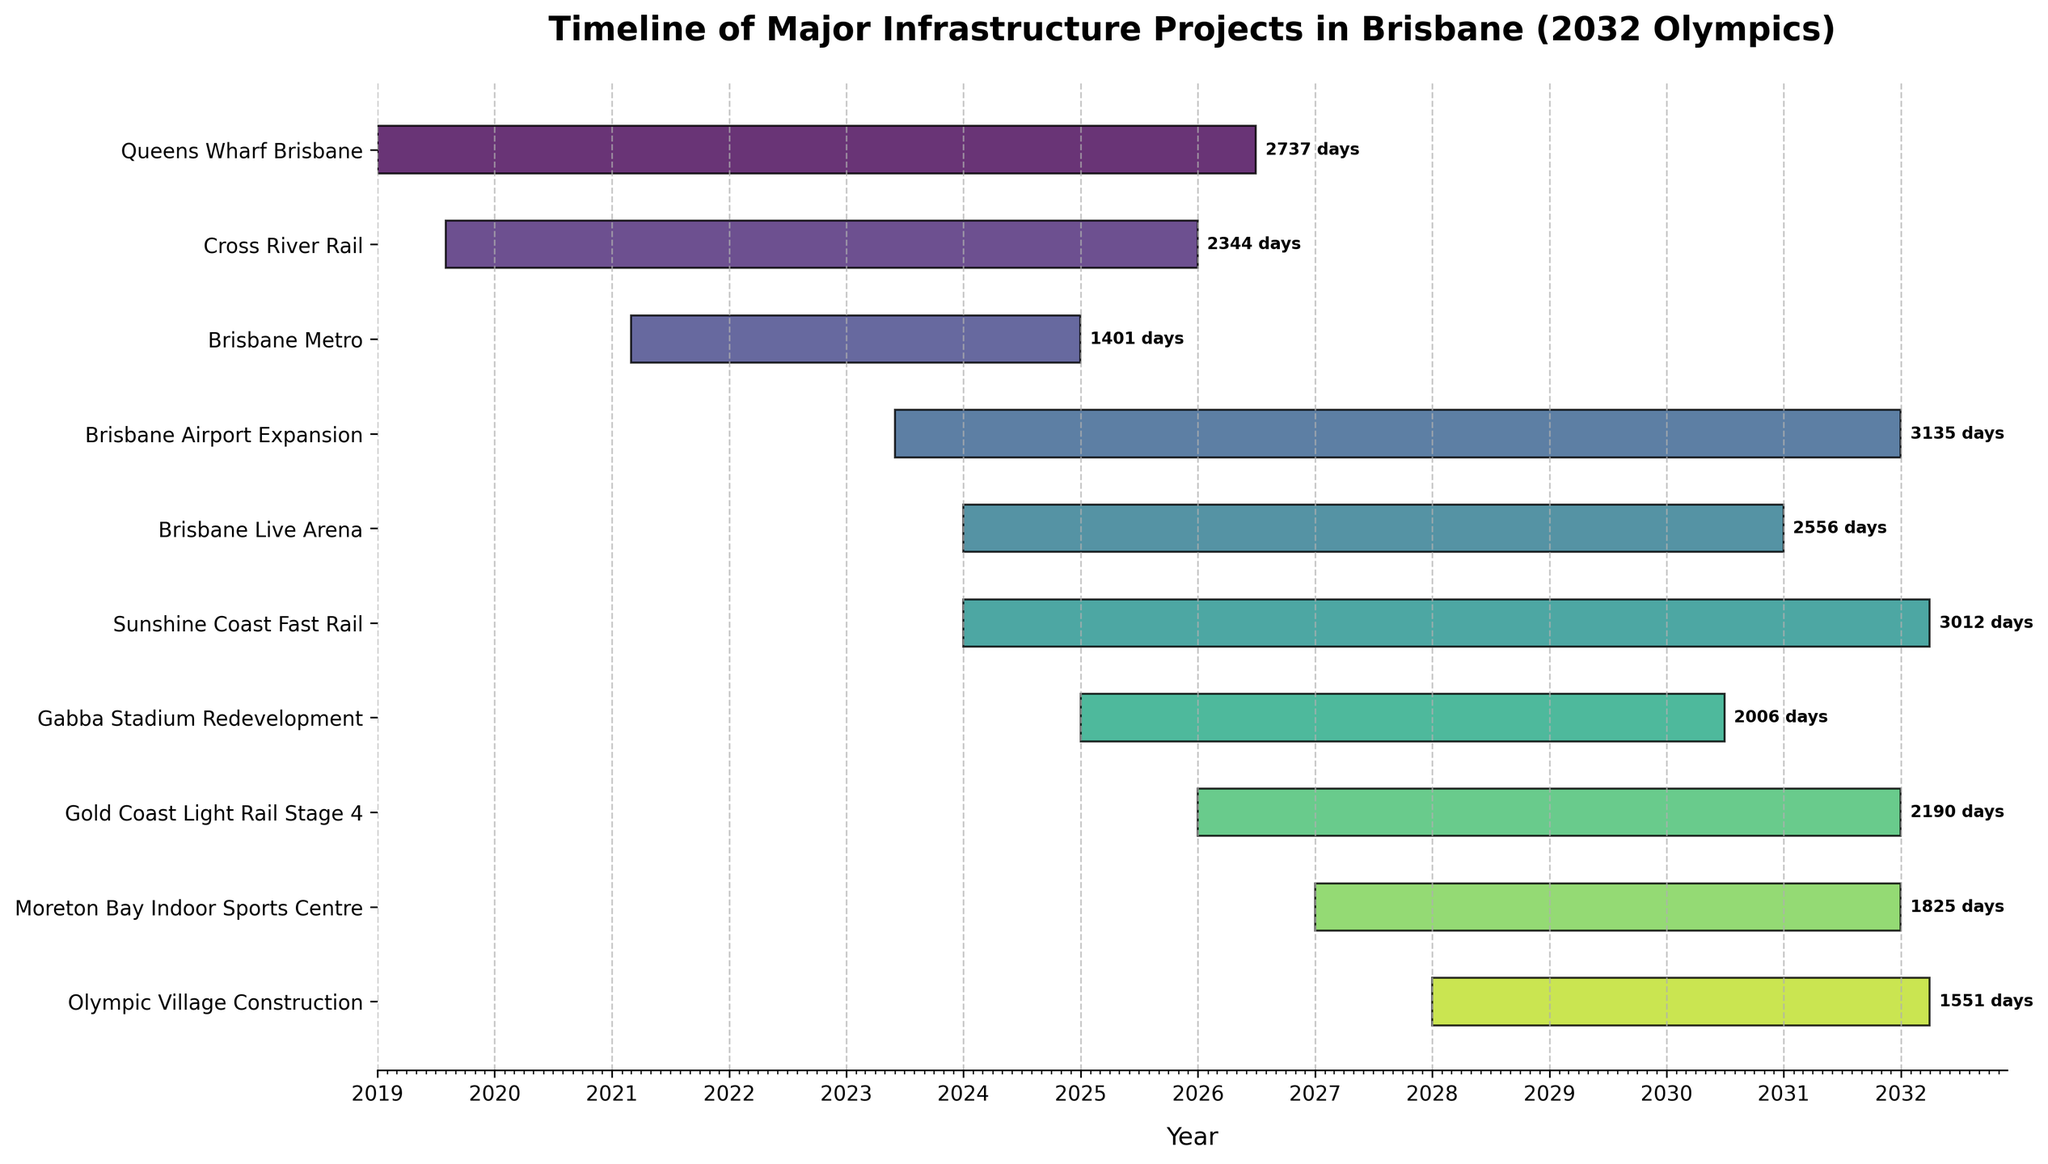What is the title of the Gantt chart? The title of a Gantt chart is typically located at the top center of the figure. By reading the title, we can identify the subject of the visualization.
Answer: Timeline of Major Infrastructure Projects in Brisbane (2032 Olympics) Which project is expected to finish first? To determine this, we look at the end dates on the right side of the bars in the chart. The project with the earliest end date finishes first.
Answer: Brisbane Metro What is the duration of the Cross River Rail project in days? The duration is given by the length of the bar. We can determine this by the text label at the end of the bar next to the project name, indicating the number of days.
Answer: 1614 days Which project has the longest duration? To identify the longest project, find the bar that spans the most years on the horizontal axis by comparing the lengths visually.
Answer: Olympic Village Construction Is the Gabba Stadium Redevelopment expected to be finished before the Sunshine Coast Fast Rail project starts? To answer this, we observe the end date of the Gabba Stadium Redevelopment and the start date of the Sunshine Coast Fast Rail project and compare them.
Answer: No During which years does the Brisbane Airport Expansion project take place? Examine the start and end dates of the Brisbane Airport Expansion bar to see how many and which years they span on the horizontal axis.
Answer: 2023-2031 Which projects are expected to start in the same year? Look at the left edges of the bars and identify the projects that begin within the same vertical line segment or year markers.
Answer: Brisbane Live Arena and Sunshine Coast Fast Rail (2024); Gold Coast Light Rail Stage 4 and Gabba Stadium Redevelopment (2026) What is the total number of projects expected to be completed by 2031? Identify and count the projects whose end dates are before or during the year 2031.
Answer: Five projects (Brisbane Metro, Cross River Rail, Queens Wharf Brisbane, Brisbane Airport Expansion, Gold Coast Light Rail Stage 4) Which project has the earliest start date? Look for the project bar that starts furthest to the left on the timeline, indicating the earliest start date.
Answer: Queens Wharf Brisbane How many projects start after 2025? Count the project bars that begin at or after the year 2026 by examining their left edges and comparing them to the year markers.
Answer: Four projects (Gold Coast Light Rail Stage 4, Moreton Bay Indoor Sports Centre, Olympic Village Construction, Gabba Stadium Redevelopment) 